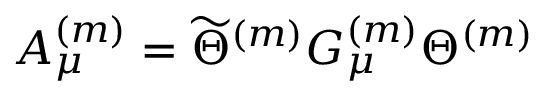<formula> <loc_0><loc_0><loc_500><loc_500>A _ { \mu } ^ { ( m ) } = \widetilde { \Theta } ^ { ( m ) } G _ { \mu } ^ { ( m ) } \Theta ^ { ( m ) }</formula> 